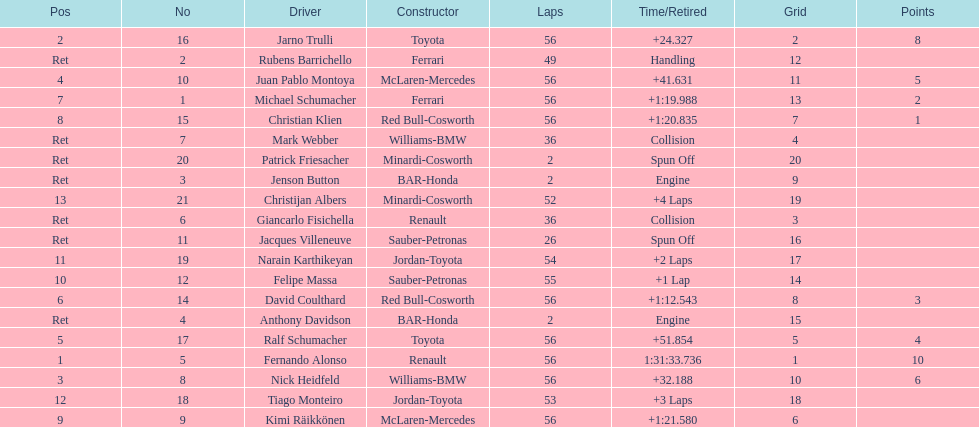What were the total number of laps completed by the 1st position winner? 56. 